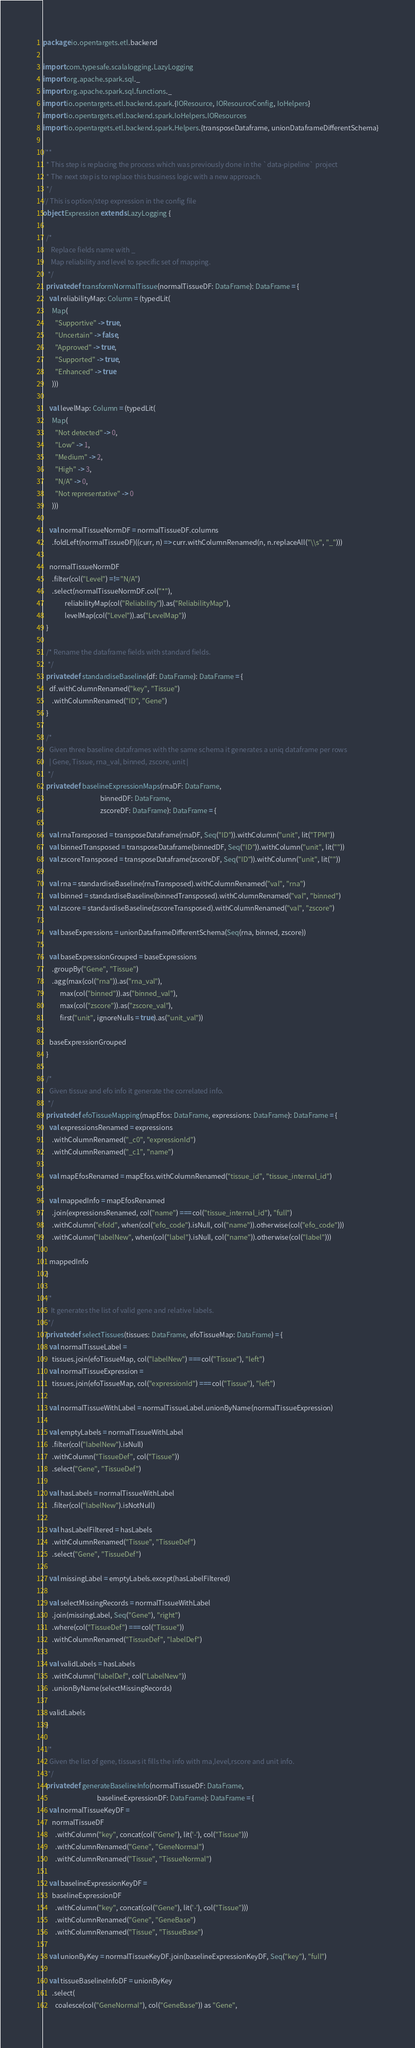Convert code to text. <code><loc_0><loc_0><loc_500><loc_500><_Scala_>package io.opentargets.etl.backend

import com.typesafe.scalalogging.LazyLogging
import org.apache.spark.sql._
import org.apache.spark.sql.functions._
import io.opentargets.etl.backend.spark.{IOResource, IOResourceConfig, IoHelpers}
import io.opentargets.etl.backend.spark.IoHelpers.IOResources
import io.opentargets.etl.backend.spark.Helpers.{transposeDataframe, unionDataframeDifferentSchema}

/**
  * This step is replacing the process which was previously done in the `data-pipeline` project
  * The next step is to replace this business logic with a new approach.
  */
// This is option/step expression in the config file
object Expression extends LazyLogging {

  /*
     Replace fields name with _
     Map reliability and level to specific set of mapping.
   */
  private def transformNormalTissue(normalTissueDF: DataFrame): DataFrame = {
    val reliabilityMap: Column = (typedLit(
      Map(
        "Supportive" -> true,
        "Uncertain" -> false,
        "Approved" -> true,
        "Supported" -> true,
        "Enhanced" -> true
      )))

    val levelMap: Column = (typedLit(
      Map(
        "Not detected" -> 0,
        "Low" -> 1,
        "Medium" -> 2,
        "High" -> 3,
        "N/A" -> 0,
        "Not representative" -> 0
      )))

    val normalTissueNormDF = normalTissueDF.columns
      .foldLeft(normalTissueDF)((curr, n) => curr.withColumnRenamed(n, n.replaceAll("\\s", "_")))

    normalTissueNormDF
      .filter(col("Level") =!= "N/A")
      .select(normalTissueNormDF.col("*"),
              reliabilityMap(col("Reliability")).as("ReliabilityMap"),
              levelMap(col("Level")).as("LevelMap"))
  }

  /* Rename the dataframe fields with standard fields.
   */
  private def standardiseBaseline(df: DataFrame): DataFrame = {
    df.withColumnRenamed("key", "Tissue")
      .withColumnRenamed("ID", "Gene")
  }

  /*
    Given three baseline dataframes with the same schema it generates a uniq dataframe per rows
    | Gene, Tissue, rna_val, binned, zscore, unit |
   */
  private def baselineExpressionMaps(rnaDF: DataFrame,
                                     binnedDF: DataFrame,
                                     zscoreDF: DataFrame): DataFrame = {

    val rnaTransposed = transposeDataframe(rnaDF, Seq("ID")).withColumn("unit", lit("TPM"))
    val binnedTransposed = transposeDataframe(binnedDF, Seq("ID")).withColumn("unit", lit(""))
    val zscoreTransposed = transposeDataframe(zscoreDF, Seq("ID")).withColumn("unit", lit(""))

    val rna = standardiseBaseline(rnaTransposed).withColumnRenamed("val", "rna")
    val binned = standardiseBaseline(binnedTransposed).withColumnRenamed("val", "binned")
    val zscore = standardiseBaseline(zscoreTransposed).withColumnRenamed("val", "zscore")

    val baseExpressions = unionDataframeDifferentSchema(Seq(rna, binned, zscore))

    val baseExpressionGrouped = baseExpressions
      .groupBy("Gene", "Tissue")
      .agg(max(col("rna")).as("rna_val"),
           max(col("binned")).as("binned_val"),
           max(col("zscore")).as("zscore_val"),
           first("unit", ignoreNulls = true).as("unit_val"))

    baseExpressionGrouped
  }

  /*
    Given tissue and efo info it generate the correlated info.
   */
  private def efoTissueMapping(mapEfos: DataFrame, expressions: DataFrame): DataFrame = {
    val expressionsRenamed = expressions
      .withColumnRenamed("_c0", "expressionId")
      .withColumnRenamed("_c1", "name")

    val mapEfosRenamed = mapEfos.withColumnRenamed("tissue_id", "tissue_internal_id")

    val mappedInfo = mapEfosRenamed
      .join(expressionsRenamed, col("name") === col("tissue_internal_id"), "full")
      .withColumn("efoId", when(col("efo_code").isNull, col("name")).otherwise(col("efo_code")))
      .withColumn("labelNew", when(col("label").isNull, col("name")).otherwise(col("label")))

    mappedInfo
  }

  /*
     It generates the list of valid gene and relative labels.
   */
  private def selectTissues(tissues: DataFrame, efoTissueMap: DataFrame) = {
    val normalTissueLabel =
      tissues.join(efoTissueMap, col("labelNew") === col("Tissue"), "left")
    val normalTissueExpression =
      tissues.join(efoTissueMap, col("expressionId") === col("Tissue"), "left")

    val normalTissueWithLabel = normalTissueLabel.unionByName(normalTissueExpression)

    val emptyLabels = normalTissueWithLabel
      .filter(col("labelNew").isNull)
      .withColumn("TissueDef", col("Tissue"))
      .select("Gene", "TissueDef")

    val hasLabels = normalTissueWithLabel
      .filter(col("labelNew").isNotNull)

    val hasLabelFiltered = hasLabels
      .withColumnRenamed("Tissue", "TissueDef")
      .select("Gene", "TissueDef")

    val missingLabel = emptyLabels.except(hasLabelFiltered)

    val selectMissingRecords = normalTissueWithLabel
      .join(missingLabel, Seq("Gene"), "right")
      .where(col("TissueDef") === col("Tissue"))
      .withColumnRenamed("TissueDef", "labelDef")

    val validLabels = hasLabels
      .withColumn("labelDef", col("LabelNew"))
      .unionByName(selectMissingRecords)

    validLabels
  }

  /*
    Given the list of gene, tissues it fills the info with rna,level,rscore and unit info.
   */
  private def generateBaselineInfo(normalTissueDF: DataFrame,
                                   baselineExpressionDF: DataFrame): DataFrame = {
    val normalTissueKeyDF =
      normalTissueDF
        .withColumn("key", concat(col("Gene"), lit('-'), col("Tissue")))
        .withColumnRenamed("Gene", "GeneNormal")
        .withColumnRenamed("Tissue", "TissueNormal")

    val baselineExpressionKeyDF =
      baselineExpressionDF
        .withColumn("key", concat(col("Gene"), lit('-'), col("Tissue")))
        .withColumnRenamed("Gene", "GeneBase")
        .withColumnRenamed("Tissue", "TissueBase")

    val unionByKey = normalTissueKeyDF.join(baselineExpressionKeyDF, Seq("key"), "full")

    val tissueBaselineInfoDF = unionByKey
      .select(
        coalesce(col("GeneNormal"), col("GeneBase")) as "Gene",</code> 